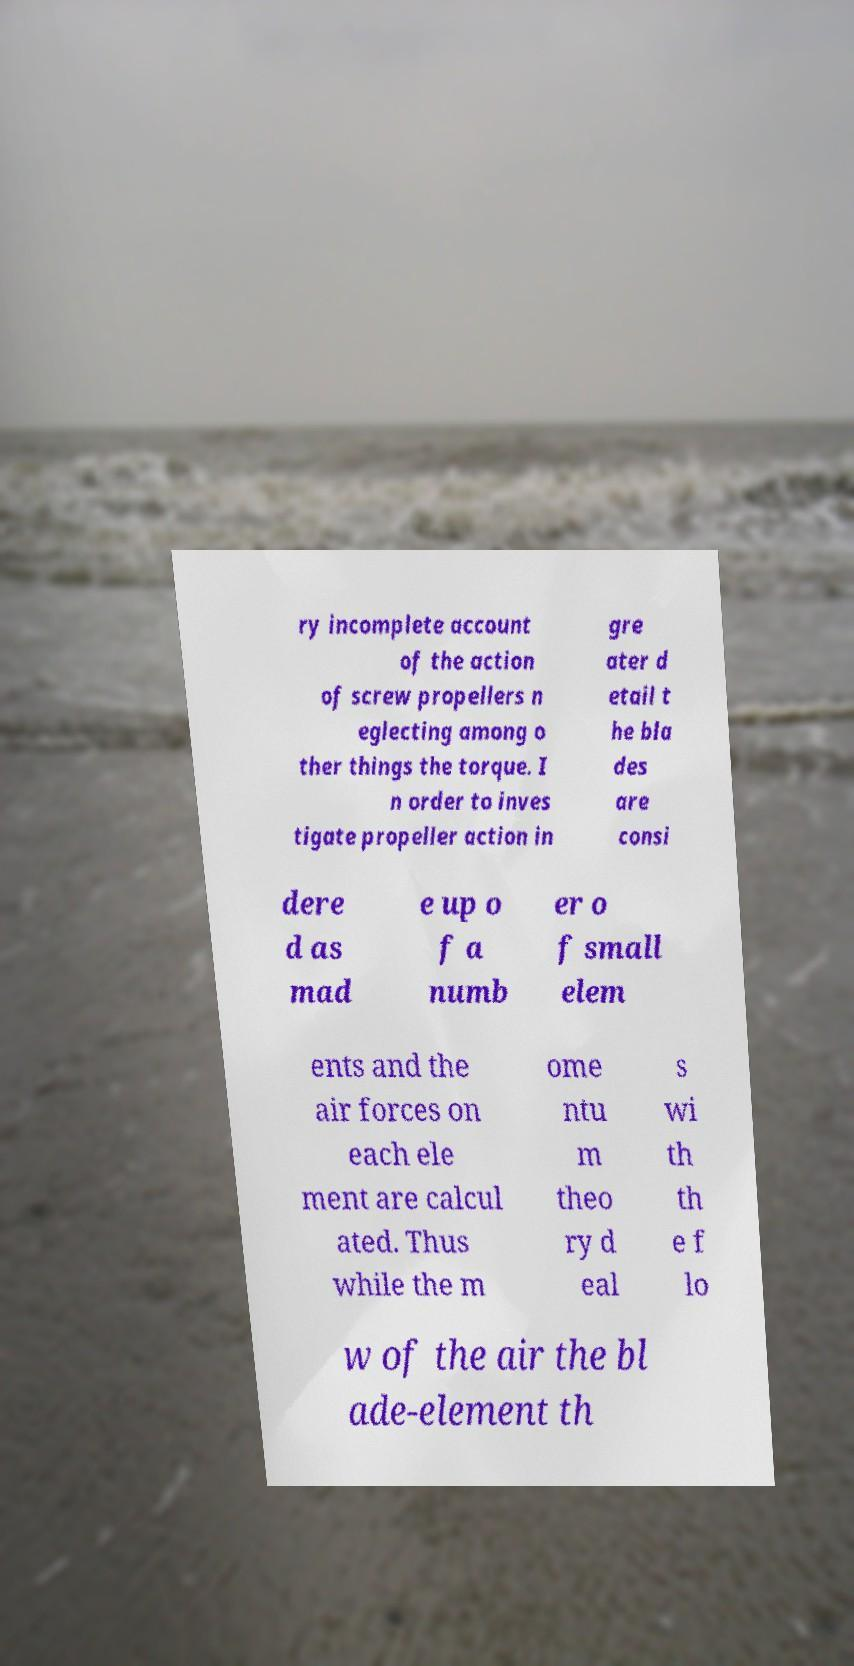What messages or text are displayed in this image? I need them in a readable, typed format. ry incomplete account of the action of screw propellers n eglecting among o ther things the torque. I n order to inves tigate propeller action in gre ater d etail t he bla des are consi dere d as mad e up o f a numb er o f small elem ents and the air forces on each ele ment are calcul ated. Thus while the m ome ntu m theo ry d eal s wi th th e f lo w of the air the bl ade-element th 